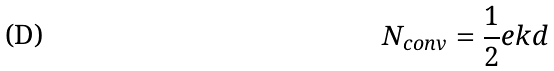Convert formula to latex. <formula><loc_0><loc_0><loc_500><loc_500>N _ { c o n v } = \frac { 1 } { 2 } e k d</formula> 